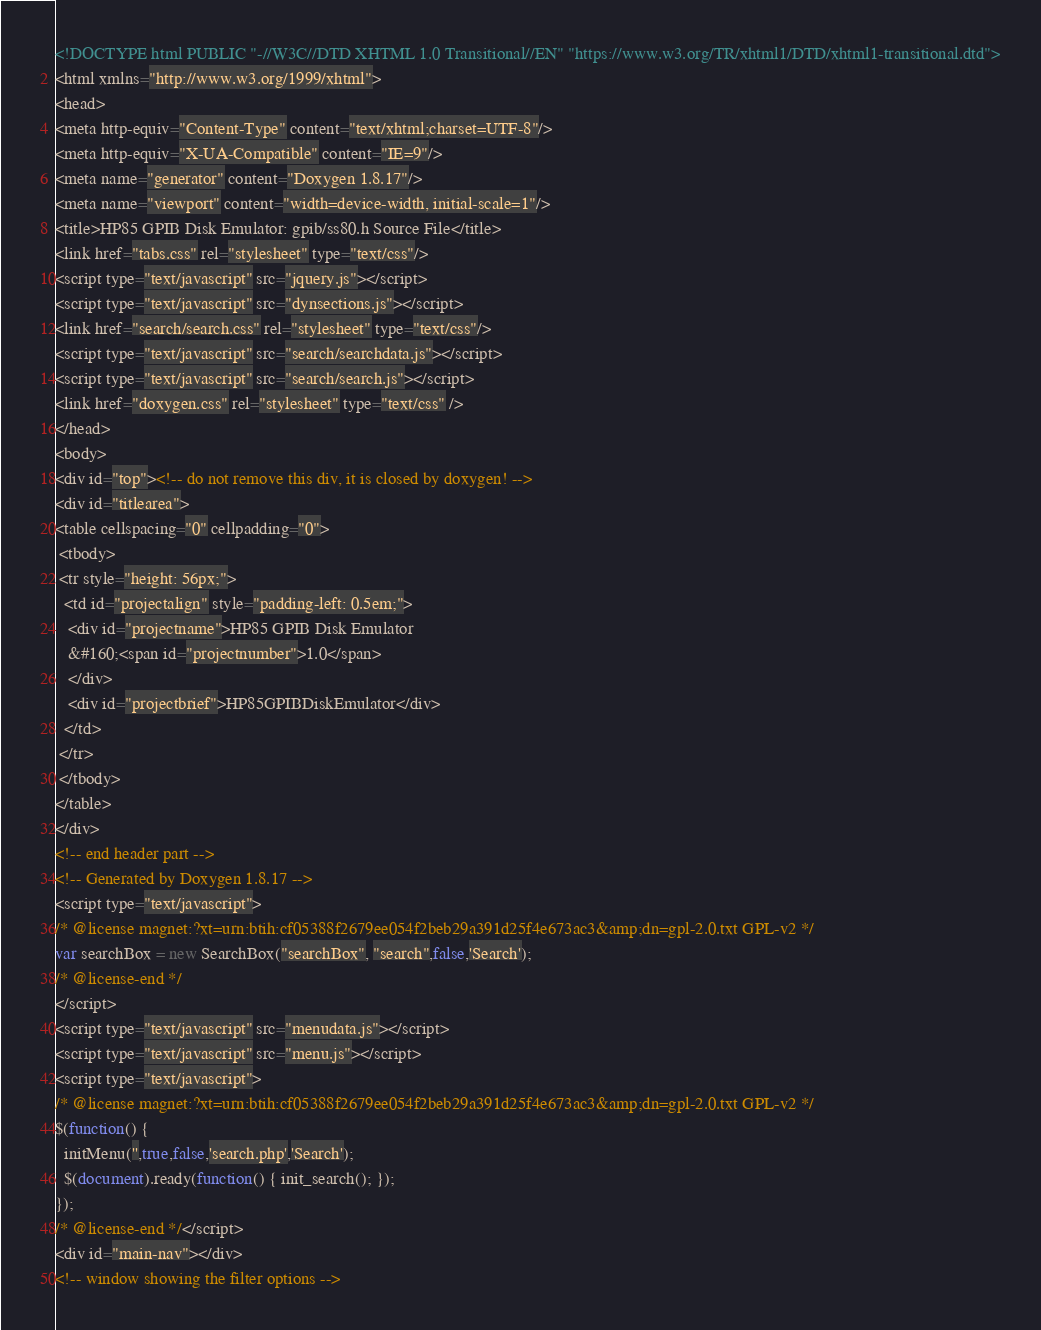Convert code to text. <code><loc_0><loc_0><loc_500><loc_500><_HTML_><!DOCTYPE html PUBLIC "-//W3C//DTD XHTML 1.0 Transitional//EN" "https://www.w3.org/TR/xhtml1/DTD/xhtml1-transitional.dtd">
<html xmlns="http://www.w3.org/1999/xhtml">
<head>
<meta http-equiv="Content-Type" content="text/xhtml;charset=UTF-8"/>
<meta http-equiv="X-UA-Compatible" content="IE=9"/>
<meta name="generator" content="Doxygen 1.8.17"/>
<meta name="viewport" content="width=device-width, initial-scale=1"/>
<title>HP85 GPIB Disk Emulator: gpib/ss80.h Source File</title>
<link href="tabs.css" rel="stylesheet" type="text/css"/>
<script type="text/javascript" src="jquery.js"></script>
<script type="text/javascript" src="dynsections.js"></script>
<link href="search/search.css" rel="stylesheet" type="text/css"/>
<script type="text/javascript" src="search/searchdata.js"></script>
<script type="text/javascript" src="search/search.js"></script>
<link href="doxygen.css" rel="stylesheet" type="text/css" />
</head>
<body>
<div id="top"><!-- do not remove this div, it is closed by doxygen! -->
<div id="titlearea">
<table cellspacing="0" cellpadding="0">
 <tbody>
 <tr style="height: 56px;">
  <td id="projectalign" style="padding-left: 0.5em;">
   <div id="projectname">HP85 GPIB Disk Emulator
   &#160;<span id="projectnumber">1.0</span>
   </div>
   <div id="projectbrief">HP85GPIBDiskEmulator</div>
  </td>
 </tr>
 </tbody>
</table>
</div>
<!-- end header part -->
<!-- Generated by Doxygen 1.8.17 -->
<script type="text/javascript">
/* @license magnet:?xt=urn:btih:cf05388f2679ee054f2beb29a391d25f4e673ac3&amp;dn=gpl-2.0.txt GPL-v2 */
var searchBox = new SearchBox("searchBox", "search",false,'Search');
/* @license-end */
</script>
<script type="text/javascript" src="menudata.js"></script>
<script type="text/javascript" src="menu.js"></script>
<script type="text/javascript">
/* @license magnet:?xt=urn:btih:cf05388f2679ee054f2beb29a391d25f4e673ac3&amp;dn=gpl-2.0.txt GPL-v2 */
$(function() {
  initMenu('',true,false,'search.php','Search');
  $(document).ready(function() { init_search(); });
});
/* @license-end */</script>
<div id="main-nav"></div>
<!-- window showing the filter options --></code> 